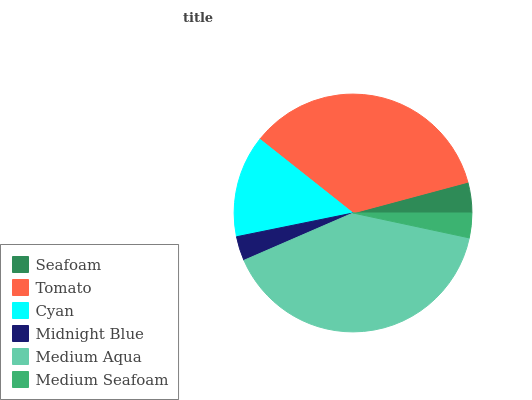Is Midnight Blue the minimum?
Answer yes or no. Yes. Is Medium Aqua the maximum?
Answer yes or no. Yes. Is Tomato the minimum?
Answer yes or no. No. Is Tomato the maximum?
Answer yes or no. No. Is Tomato greater than Seafoam?
Answer yes or no. Yes. Is Seafoam less than Tomato?
Answer yes or no. Yes. Is Seafoam greater than Tomato?
Answer yes or no. No. Is Tomato less than Seafoam?
Answer yes or no. No. Is Cyan the high median?
Answer yes or no. Yes. Is Seafoam the low median?
Answer yes or no. Yes. Is Seafoam the high median?
Answer yes or no. No. Is Medium Seafoam the low median?
Answer yes or no. No. 